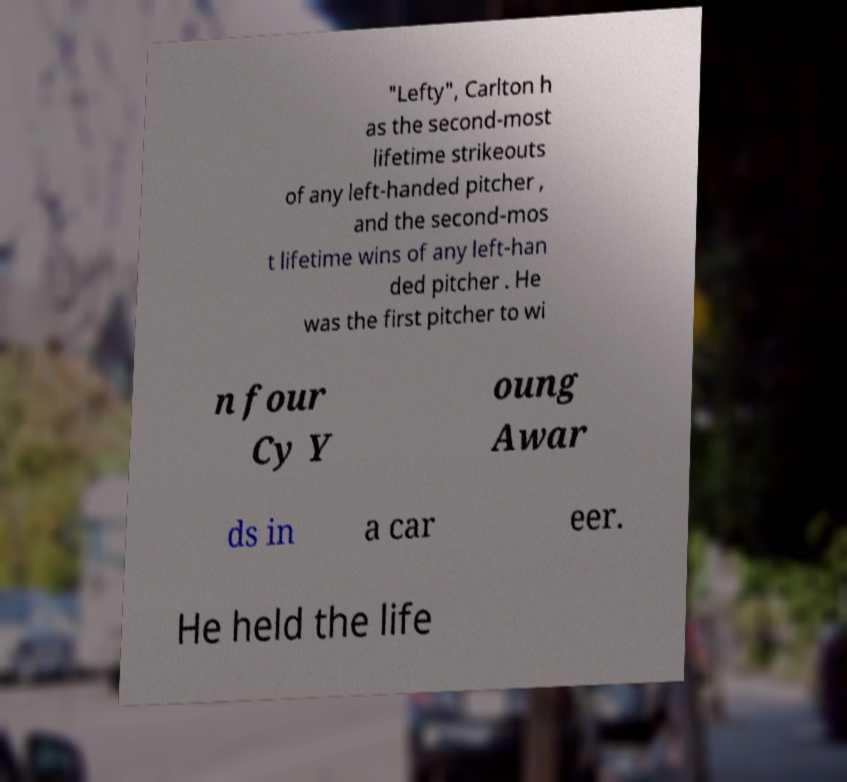What messages or text are displayed in this image? I need them in a readable, typed format. "Lefty", Carlton h as the second-most lifetime strikeouts of any left-handed pitcher , and the second-mos t lifetime wins of any left-han ded pitcher . He was the first pitcher to wi n four Cy Y oung Awar ds in a car eer. He held the life 